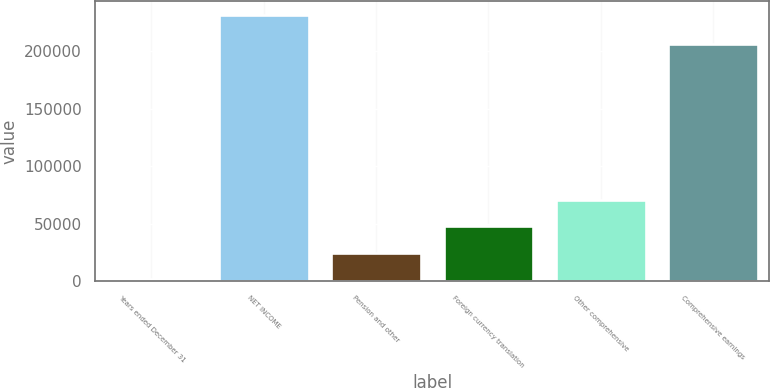Convert chart. <chart><loc_0><loc_0><loc_500><loc_500><bar_chart><fcel>Years ended December 31<fcel>NET INCOME<fcel>Pension and other<fcel>Foreign currency translation<fcel>Other comprehensive<fcel>Comprehensive earnings<nl><fcel>2018<fcel>231663<fcel>24982.5<fcel>47947<fcel>70911.5<fcel>206541<nl></chart> 